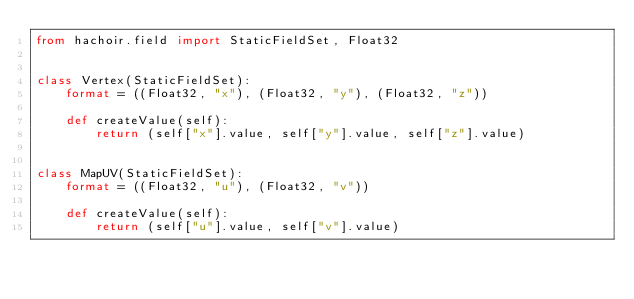Convert code to text. <code><loc_0><loc_0><loc_500><loc_500><_Python_>from hachoir.field import StaticFieldSet, Float32


class Vertex(StaticFieldSet):
    format = ((Float32, "x"), (Float32, "y"), (Float32, "z"))

    def createValue(self):
        return (self["x"].value, self["y"].value, self["z"].value)


class MapUV(StaticFieldSet):
    format = ((Float32, "u"), (Float32, "v"))

    def createValue(self):
        return (self["u"].value, self["v"].value)
</code> 